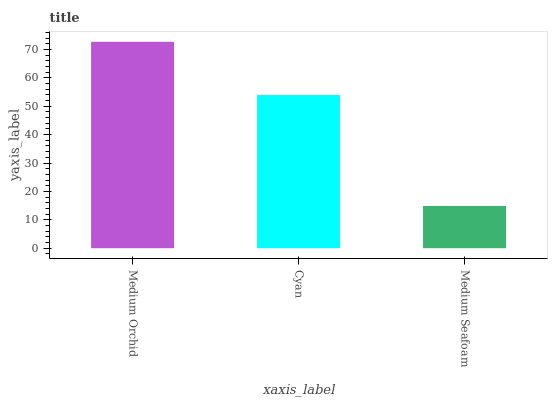Is Medium Seafoam the minimum?
Answer yes or no. Yes. Is Medium Orchid the maximum?
Answer yes or no. Yes. Is Cyan the minimum?
Answer yes or no. No. Is Cyan the maximum?
Answer yes or no. No. Is Medium Orchid greater than Cyan?
Answer yes or no. Yes. Is Cyan less than Medium Orchid?
Answer yes or no. Yes. Is Cyan greater than Medium Orchid?
Answer yes or no. No. Is Medium Orchid less than Cyan?
Answer yes or no. No. Is Cyan the high median?
Answer yes or no. Yes. Is Cyan the low median?
Answer yes or no. Yes. Is Medium Orchid the high median?
Answer yes or no. No. Is Medium Orchid the low median?
Answer yes or no. No. 